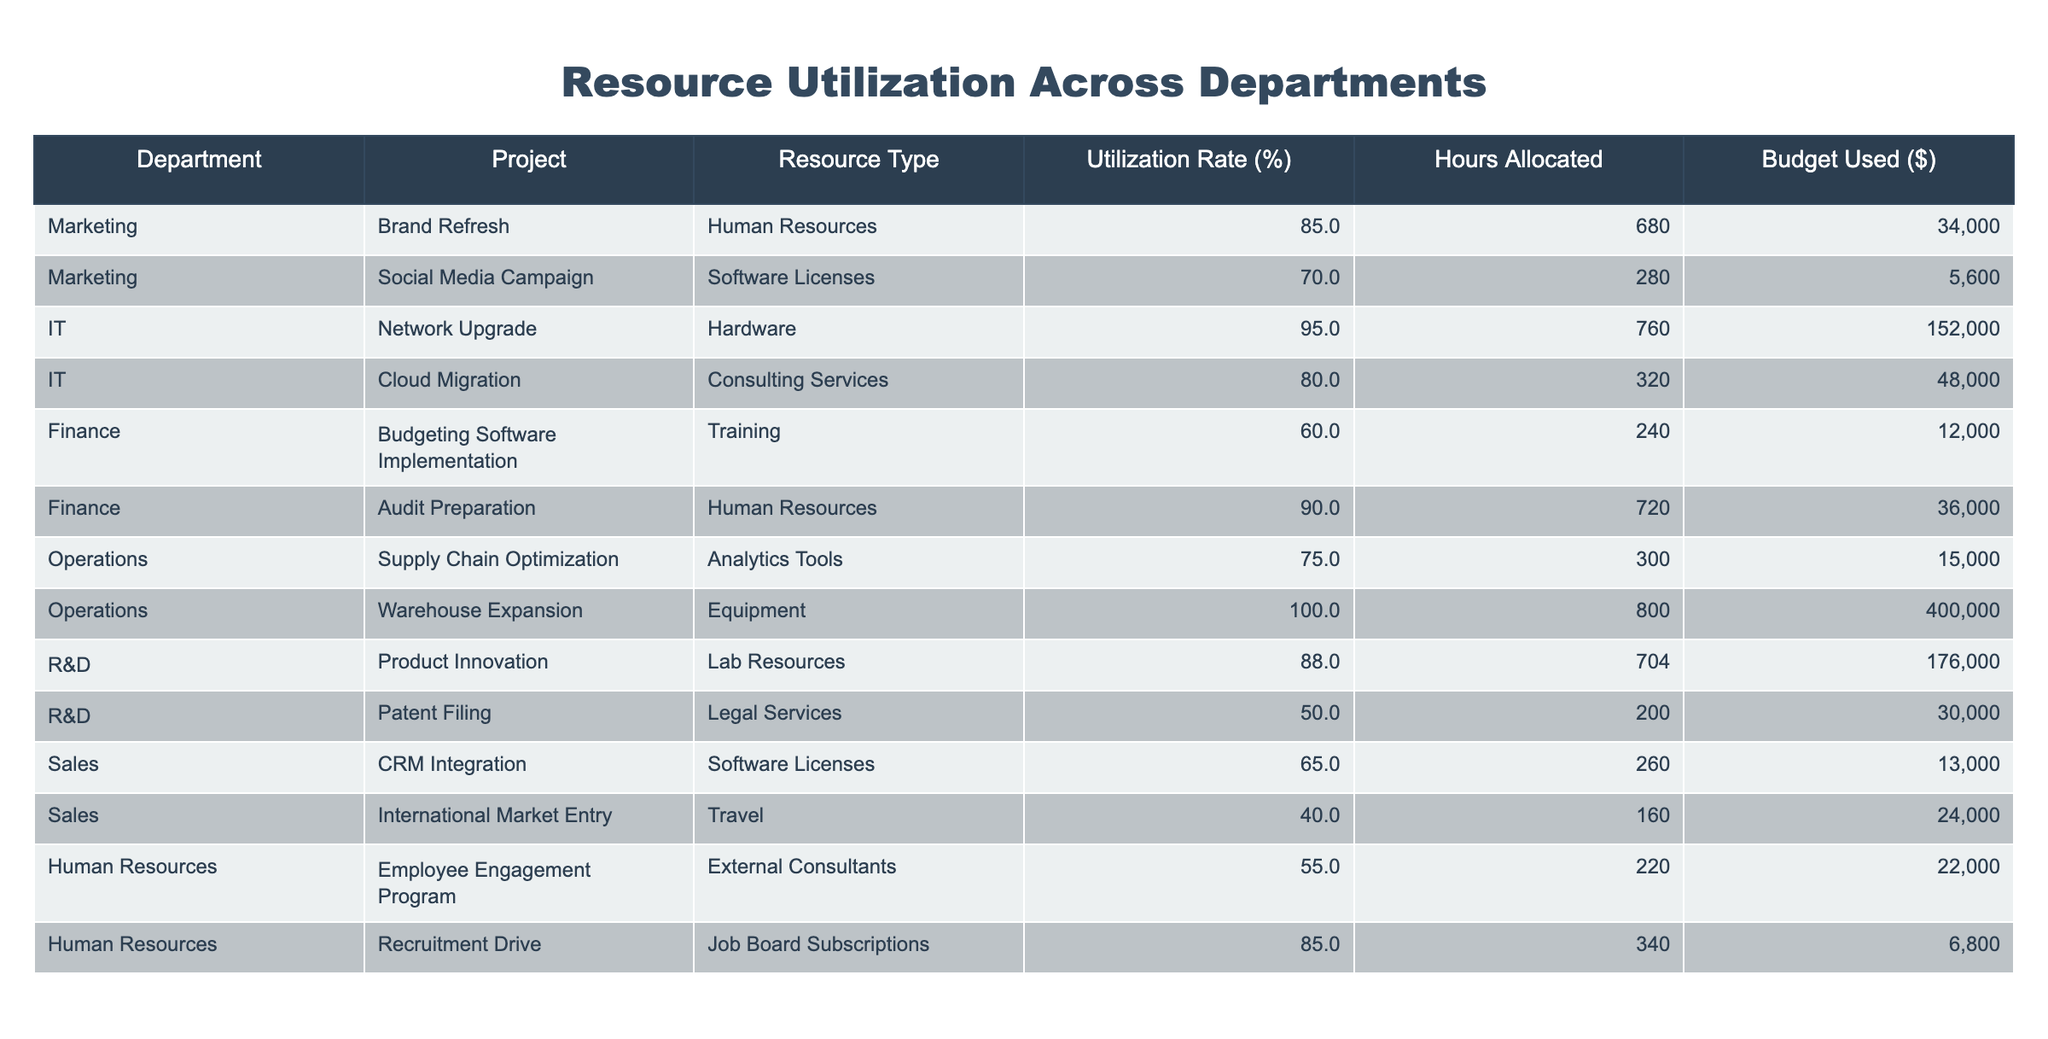What is the utilization rate for the Marketing department's Brand Refresh project? In the table, I can see that under the Marketing department and the Brand Refresh project, the utilization rate is listed as 85%.
Answer: 85% Which project in the IT department has the highest budget used? Looking at the IT department, the Network Upgrade project shows a budget used of $152,000, which is higher than the Cloud Migration project's $48,000. Therefore, the highest budget used in the IT department is for the Network Upgrade project.
Answer: Network Upgrade What is the average utilization rate for all projects listed in the Operations department? The total utilization rates for the Operations department projects are 75% and 100%. To find the average, I sum the two rates (75 + 100 = 175) and divide by the number of projects (2), which gives me an average of 87.5%.
Answer: 87.5% Are there any projects in the Finance department with a utilization rate higher than 70%? In the Finance department, the Budgeting Software Implementation project has a utilization rate of 60%, while the Audit Preparation project has a utilization rate of 90%. Since 90% is greater than 70%, the answer is yes.
Answer: Yes Which project has the lowest budget used across all departments? From the table, I can see that the Recruitment Drive project in the Human Resources department has a budget used of $6,800, and this appears to be the lowest amount compared to other projects.
Answer: Recruitment Drive What is the total budget used for all projects in the R&D department? The two projects in the R&D department are Product Innovation with $176,000 and Patent Filing with $30,000. I add these two amounts together (176,000 + 30,000 = 206,000) to get the total budget used for R&D projects.
Answer: $206,000 Does the Supply Chain Optimization project utilize more or less than 80% of resources? The Supply Chain Optimization project has a utilization rate of 75%, which is less than 80%.
Answer: Less Which department has the highest percentage of resource utilization for their projects? To find out which department has the highest utilization, I compare the highest rates across departments: Marketing (85% and 70%), IT (95% and 80%), Finance (60% and 90%), Operations (75% and 100%), R&D (88% and 50%), and Sales (65% and 40%). The IT department has the highest single rate of 95%.
Answer: IT What is the difference in allocated hours between the Warehouse Expansion project and the Audit Preparation project? The Warehouse Expansion project has 800 hours allocated, while the Audit Preparation project has 720 hours allocated. The difference is 800 - 720 = 80 hours.
Answer: 80 hours 